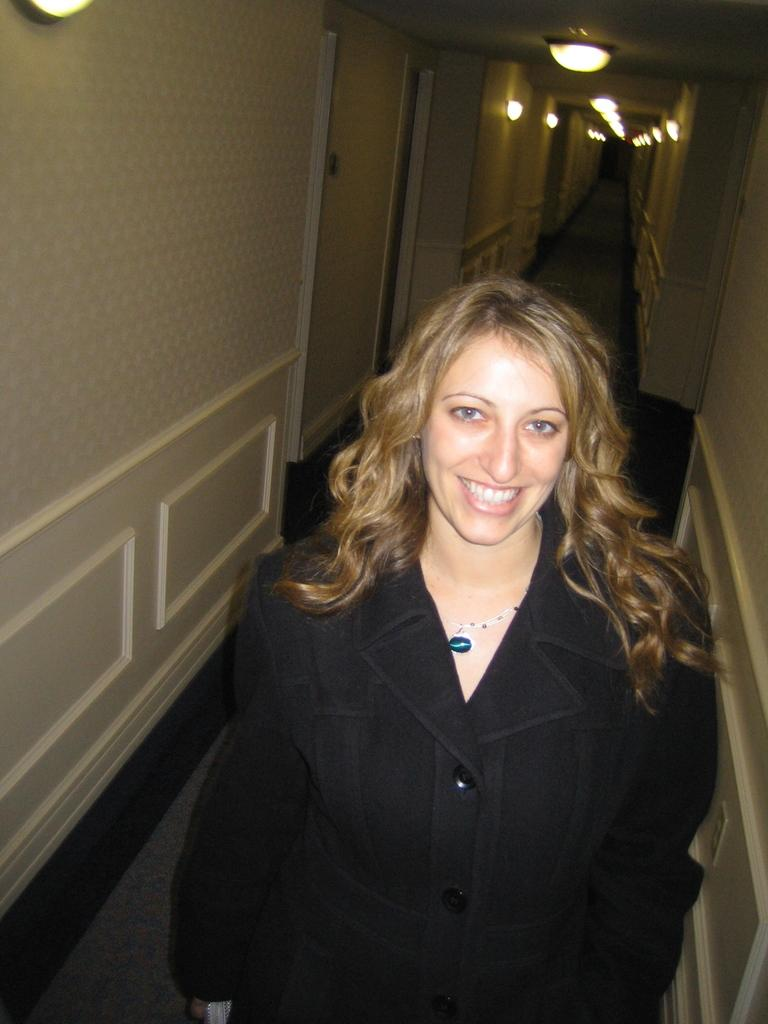Who is present in the image? There is a woman in the image. What is the woman doing in the image? The woman is standing and smiling. What can be seen in the background of the image? There are doors and lights attached to the ceiling in the background of the image. What type of fowl can be seen playing with toys in the image? There is no fowl or toys present in the image; it features a woman standing and smiling. Who is the woman's partner in the image? There is no partner present in the image; it only features the woman. 